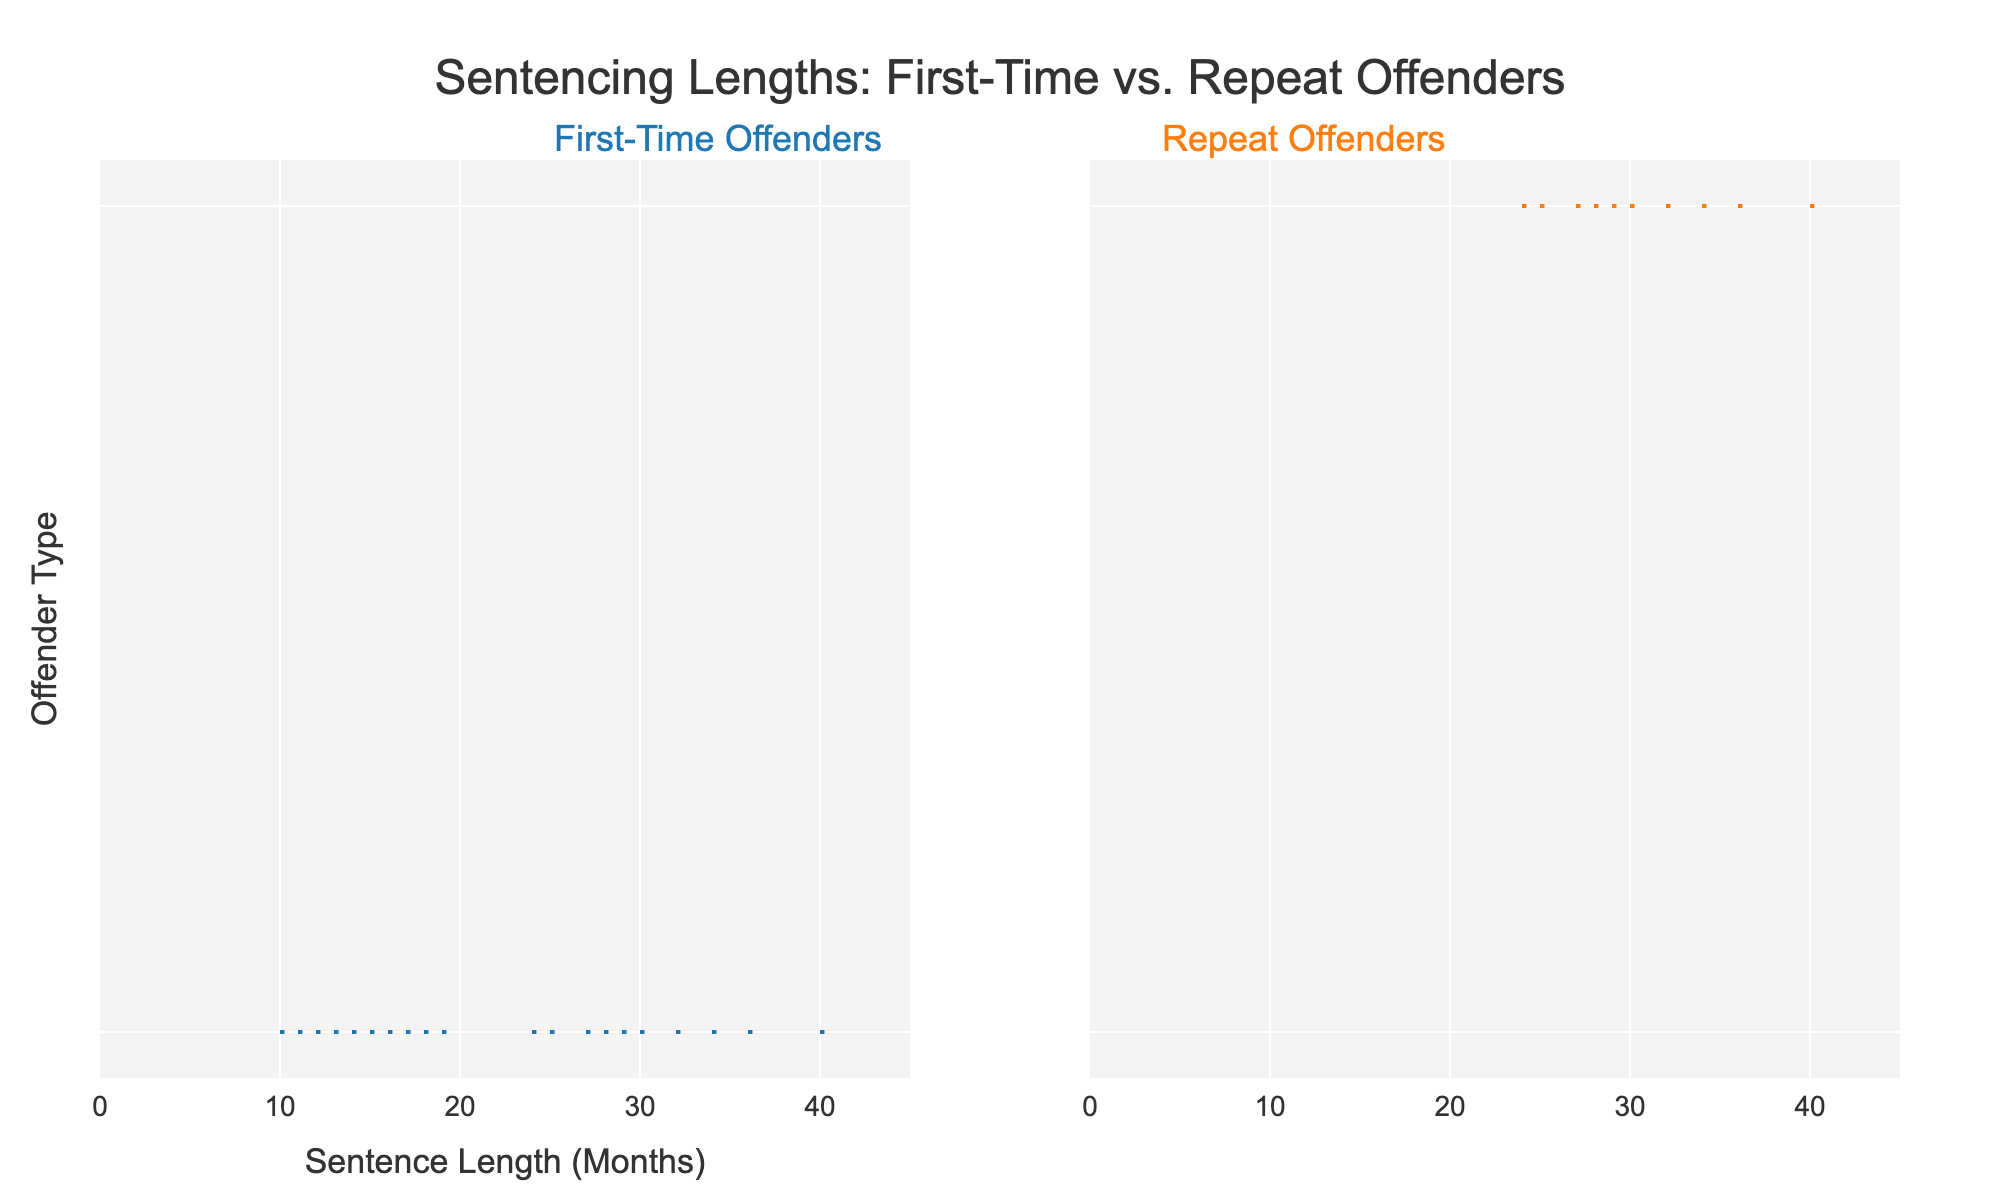What is the title of the chart? The title is located at the top center of the chart and is displayed prominently.
Answer: Sentencing Lengths: First-Time vs. Repeat Offenders What types of offenders does the chart compare? The chart has annotations at the top indicating the two types of offenders compared: first-time offenders and repeat offenders.
Answer: First-time offenders and repeat offenders Which group has higher sentence lengths on average? By observing the distributions, the repeat offenders' violin plot extends further to higher lengths in comparison to the first-time offenders' plot.
Answer: Repeat offenders How many sentence length data points are there for repeat offenders? By counting the number of individual violins (or dots) within the repeat offenders' plot.
Answer: 10 Between what ranges do the sentence lengths for first-time offenders fall? The distribution for first-time offenders can be seen falling approximately between the shortest and longest violins in the plot.
Answer: 10 to 19 months What is the median sentence length for first-time offenders? The median is the middle value in the sorted list; observe the central tendency within the distribution illustrated by the violin's bulk middle portion.
Answer: 14 months What is the color used to represent the first-time offenders? Observe the color of the violin's body under this category.
Answer: Blue What is the maximum sentence length for repeat offenders depicted in the chart? Look for the furthest extending part of the violin plot for repeat offenders.
Answer: 40 months Do any offenders, either first-time or repeat, have sentence lengths less than 10 months? Check the lower range of both distributions; neither violin plot extends below a sentence length of 10 months.
Answer: No What is the difference between the maximum sentences of repeat offenders and first-time offenders? Find the maximum sentence lengths for both groups and subtract the smaller from the larger. First-time max: 19, Repeat max: 40. Thus, 40 - 19 = 21.
Answer: 21 months 